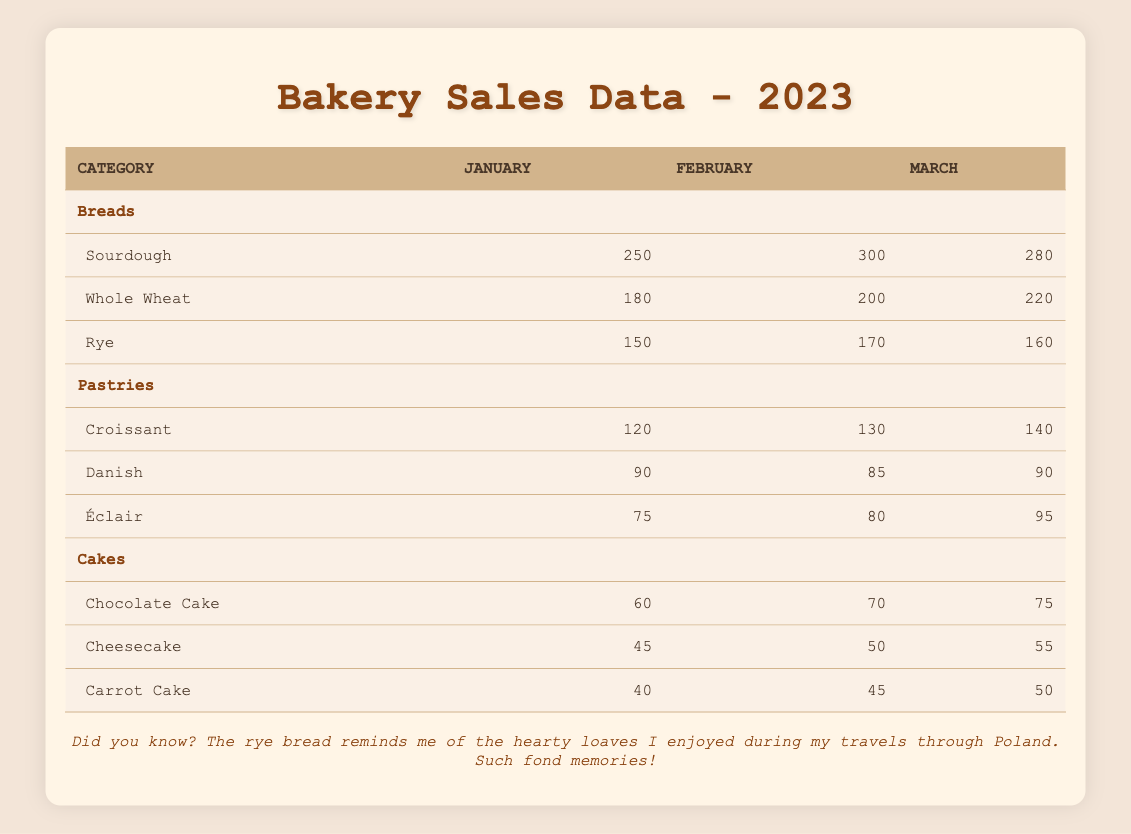What is the total number of Sourdough sales in January, February, and March? To find this, we look at the sales figures for Sourdough across the three months: January (250), February (300), and March (280). We sum these numbers: 250 + 300 + 280 = 830.
Answer: 830 Which month saw the highest sales for Chocolate Cake? By observing the sales figures for Chocolate Cake across the three months, we see January (60), February (70), and March (75). The highest value is in March at 75.
Answer: March What is the difference in sales between Whole Wheat bread in February and March? We look at the sales for Whole Wheat bread: February (200) and March (220). To find the difference, we subtract February’s sales from March's: 220 - 200 = 20.
Answer: 20 Did the sales for Éclair increase from January to March? We check the sales figures for Éclair: January (75), February (80), and March (95). Since 75 < 95, we can confirm it did increase.
Answer: Yes What is the average number of Danish sales over the three months? The sales for Danish are January (90), February (85), and March (90). To find the average, we sum these numbers: 90 + 85 + 90 = 265 and divide by 3, giving us 265 / 3 ≈ 88.33.
Answer: 88.33 